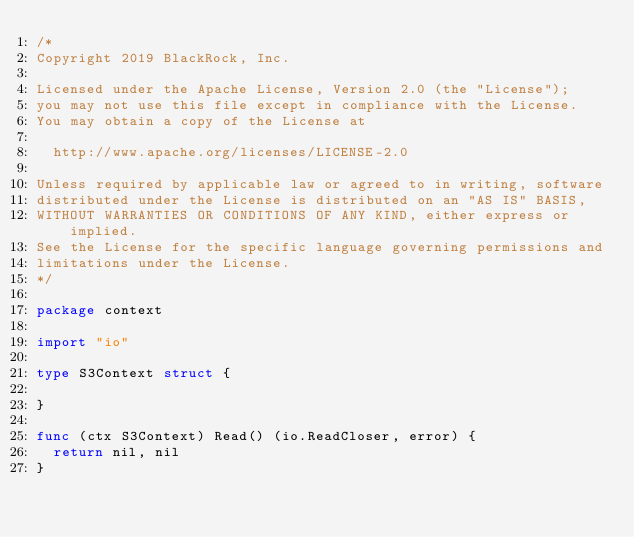Convert code to text. <code><loc_0><loc_0><loc_500><loc_500><_Go_>/*
Copyright 2019 BlackRock, Inc.

Licensed under the Apache License, Version 2.0 (the "License");
you may not use this file except in compliance with the License.
You may obtain a copy of the License at

	http://www.apache.org/licenses/LICENSE-2.0

Unless required by applicable law or agreed to in writing, software
distributed under the License is distributed on an "AS IS" BASIS,
WITHOUT WARRANTIES OR CONDITIONS OF ANY KIND, either express or implied.
See the License for the specific language governing permissions and
limitations under the License.
*/

package context

import "io"

type S3Context struct {

}

func (ctx S3Context) Read() (io.ReadCloser, error) {
	return nil, nil
}
</code> 